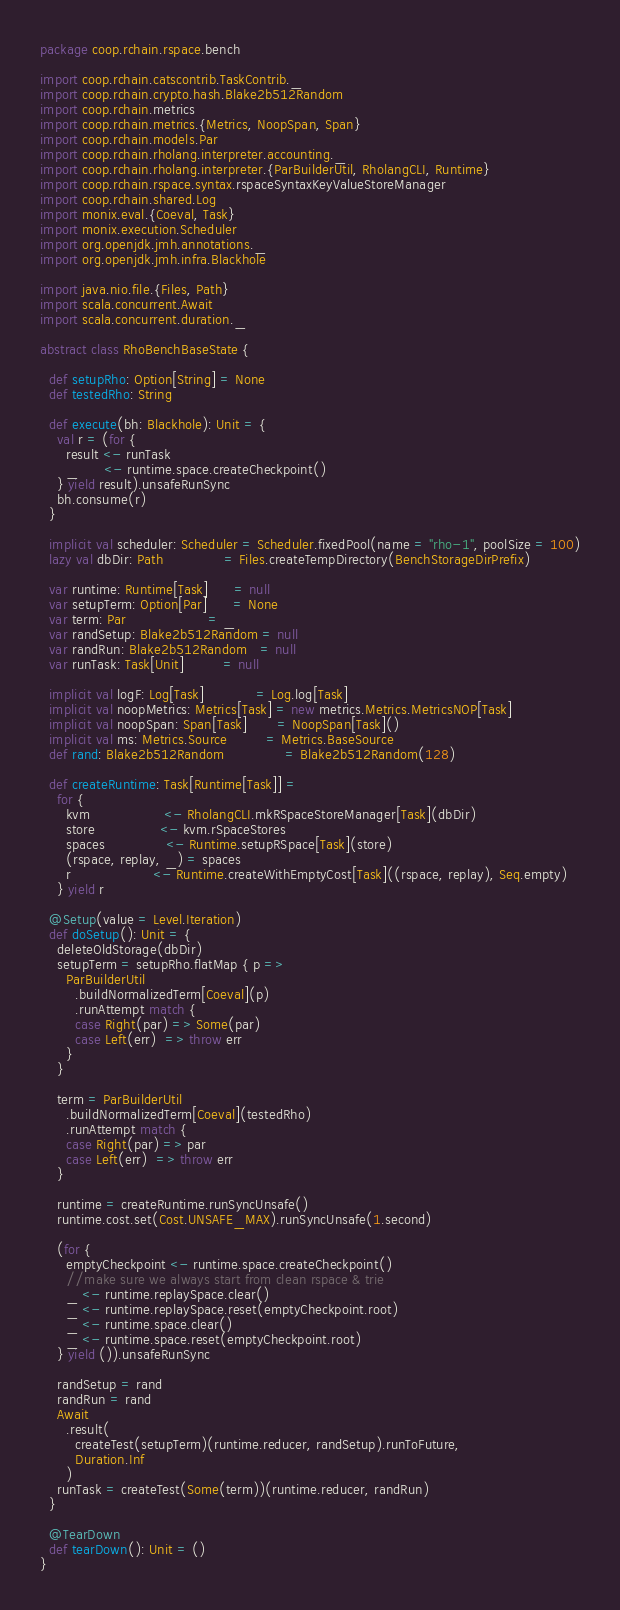<code> <loc_0><loc_0><loc_500><loc_500><_Scala_>package coop.rchain.rspace.bench

import coop.rchain.catscontrib.TaskContrib._
import coop.rchain.crypto.hash.Blake2b512Random
import coop.rchain.metrics
import coop.rchain.metrics.{Metrics, NoopSpan, Span}
import coop.rchain.models.Par
import coop.rchain.rholang.interpreter.accounting._
import coop.rchain.rholang.interpreter.{ParBuilderUtil, RholangCLI, Runtime}
import coop.rchain.rspace.syntax.rspaceSyntaxKeyValueStoreManager
import coop.rchain.shared.Log
import monix.eval.{Coeval, Task}
import monix.execution.Scheduler
import org.openjdk.jmh.annotations._
import org.openjdk.jmh.infra.Blackhole

import java.nio.file.{Files, Path}
import scala.concurrent.Await
import scala.concurrent.duration._

abstract class RhoBenchBaseState {

  def setupRho: Option[String] = None
  def testedRho: String

  def execute(bh: Blackhole): Unit = {
    val r = (for {
      result <- runTask
      _      <- runtime.space.createCheckpoint()
    } yield result).unsafeRunSync
    bh.consume(r)
  }

  implicit val scheduler: Scheduler = Scheduler.fixedPool(name = "rho-1", poolSize = 100)
  lazy val dbDir: Path              = Files.createTempDirectory(BenchStorageDirPrefix)

  var runtime: Runtime[Task]      = null
  var setupTerm: Option[Par]      = None
  var term: Par                   = _
  var randSetup: Blake2b512Random = null
  var randRun: Blake2b512Random   = null
  var runTask: Task[Unit]         = null

  implicit val logF: Log[Task]            = Log.log[Task]
  implicit val noopMetrics: Metrics[Task] = new metrics.Metrics.MetricsNOP[Task]
  implicit val noopSpan: Span[Task]       = NoopSpan[Task]()
  implicit val ms: Metrics.Source         = Metrics.BaseSource
  def rand: Blake2b512Random              = Blake2b512Random(128)

  def createRuntime: Task[Runtime[Task]] =
    for {
      kvm                 <- RholangCLI.mkRSpaceStoreManager[Task](dbDir)
      store               <- kvm.rSpaceStores
      spaces              <- Runtime.setupRSpace[Task](store)
      (rspace, replay, _) = spaces
      r                   <- Runtime.createWithEmptyCost[Task]((rspace, replay), Seq.empty)
    } yield r

  @Setup(value = Level.Iteration)
  def doSetup(): Unit = {
    deleteOldStorage(dbDir)
    setupTerm = setupRho.flatMap { p =>
      ParBuilderUtil
        .buildNormalizedTerm[Coeval](p)
        .runAttempt match {
        case Right(par) => Some(par)
        case Left(err)  => throw err
      }
    }

    term = ParBuilderUtil
      .buildNormalizedTerm[Coeval](testedRho)
      .runAttempt match {
      case Right(par) => par
      case Left(err)  => throw err
    }

    runtime = createRuntime.runSyncUnsafe()
    runtime.cost.set(Cost.UNSAFE_MAX).runSyncUnsafe(1.second)

    (for {
      emptyCheckpoint <- runtime.space.createCheckpoint()
      //make sure we always start from clean rspace & trie
      _ <- runtime.replaySpace.clear()
      _ <- runtime.replaySpace.reset(emptyCheckpoint.root)
      _ <- runtime.space.clear()
      _ <- runtime.space.reset(emptyCheckpoint.root)
    } yield ()).unsafeRunSync

    randSetup = rand
    randRun = rand
    Await
      .result(
        createTest(setupTerm)(runtime.reducer, randSetup).runToFuture,
        Duration.Inf
      )
    runTask = createTest(Some(term))(runtime.reducer, randRun)
  }

  @TearDown
  def tearDown(): Unit = ()
}
</code> 